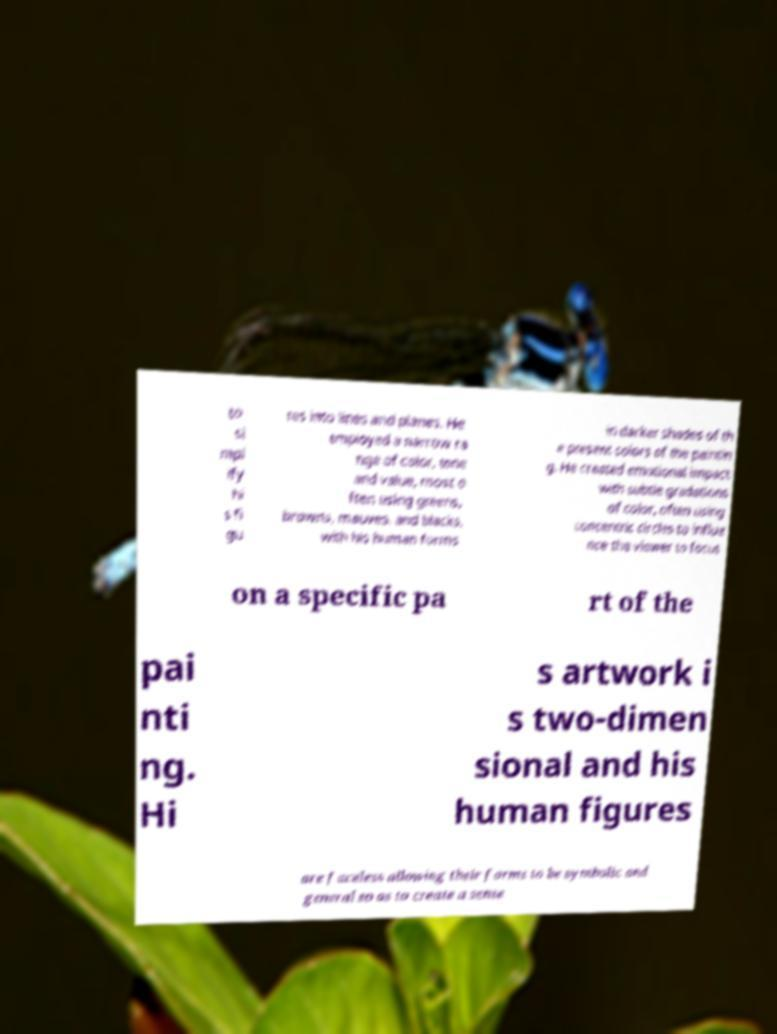There's text embedded in this image that I need extracted. Can you transcribe it verbatim? to si mpl ify hi s fi gu res into lines and planes. He employed a narrow ra nge of color, tone and value, most o ften using greens, browns, mauves, and blacks, with his human forms in darker shades of th e present colors of the paintin g. He created emotional impact with subtle gradations of color, often using concentric circles to influe nce the viewer to focus on a specific pa rt of the pai nti ng. Hi s artwork i s two-dimen sional and his human figures are faceless allowing their forms to be symbolic and general so as to create a sense 